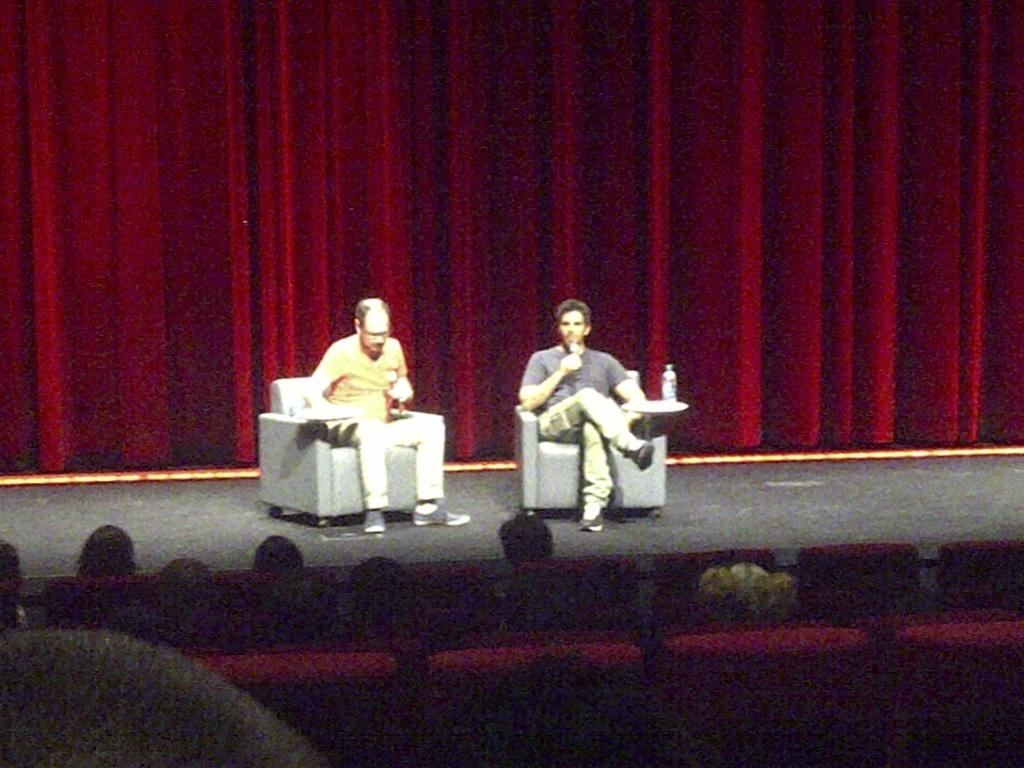What is the main feature of the image? There is a stage in the image. What are the two people on the stage doing? Both people are sitting on chairs on the stage and holding microphones. What can be seen in the background of the image? There is a curtain and people visible in the background. What type of cannon is being used by the people on the stage? There is no cannon present in the image; the people on the stage are holding microphones. How does the mind of the person sitting on the left chair on the stage look like? The image does not provide any information about the mental state or appearance of the person's mind. 